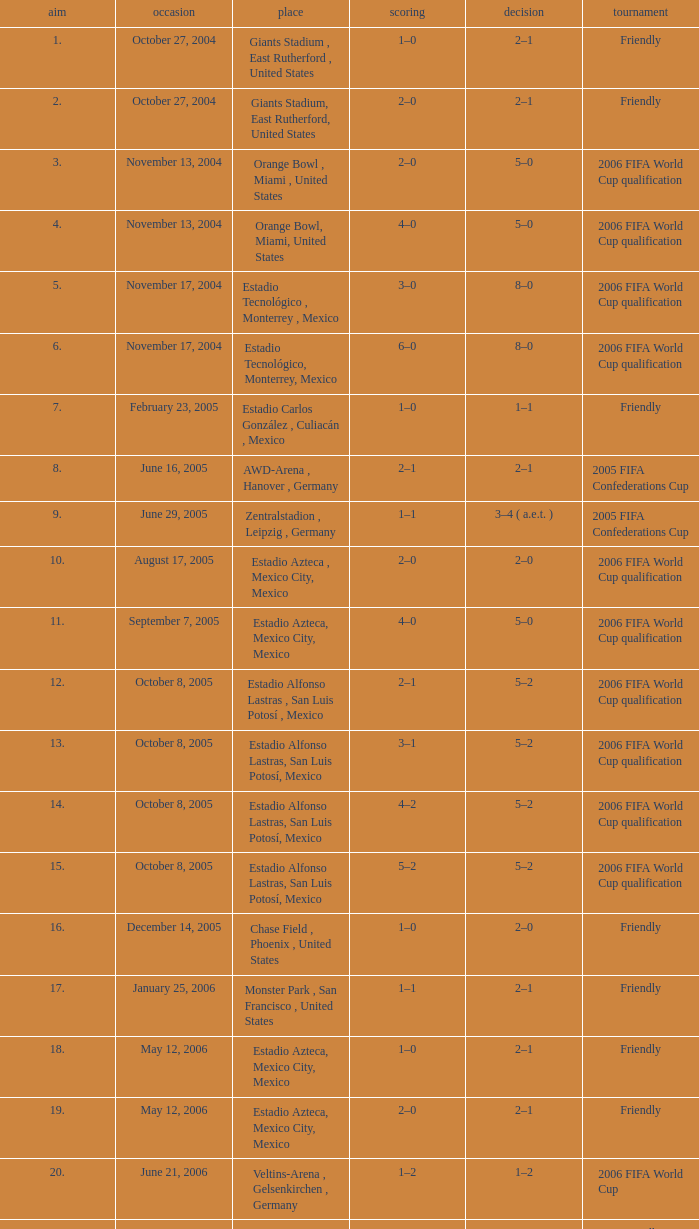Which Result has a Score of 1–0, and a Goal of 16? 2–0. 